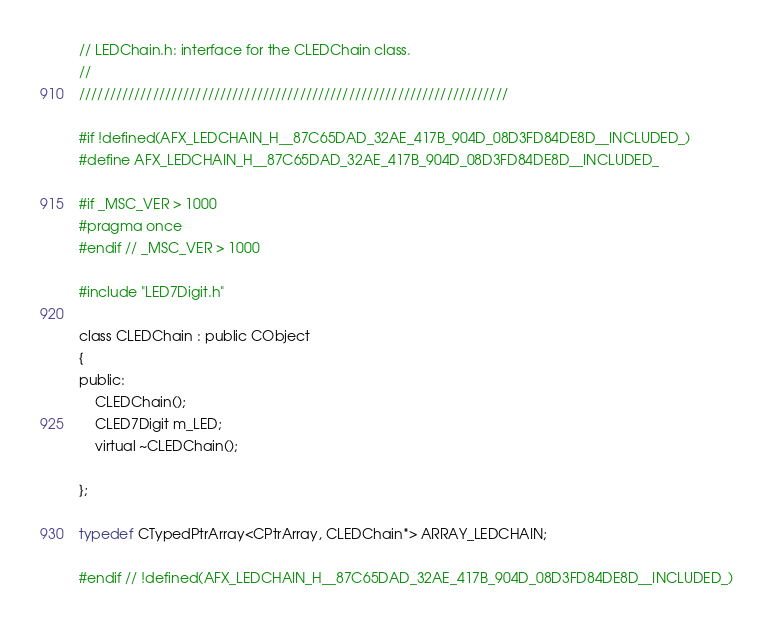<code> <loc_0><loc_0><loc_500><loc_500><_C_>// LEDChain.h: interface for the CLEDChain class.
//
//////////////////////////////////////////////////////////////////////

#if !defined(AFX_LEDCHAIN_H__87C65DAD_32AE_417B_904D_08D3FD84DE8D__INCLUDED_)
#define AFX_LEDCHAIN_H__87C65DAD_32AE_417B_904D_08D3FD84DE8D__INCLUDED_

#if _MSC_VER > 1000
#pragma once
#endif // _MSC_VER > 1000

#include "LED7Digit.h"

class CLEDChain : public CObject  
{
public:
	CLEDChain();
	CLED7Digit m_LED;
	virtual ~CLEDChain();

};

typedef CTypedPtrArray<CPtrArray, CLEDChain*> ARRAY_LEDCHAIN;

#endif // !defined(AFX_LEDCHAIN_H__87C65DAD_32AE_417B_904D_08D3FD84DE8D__INCLUDED_)
</code> 